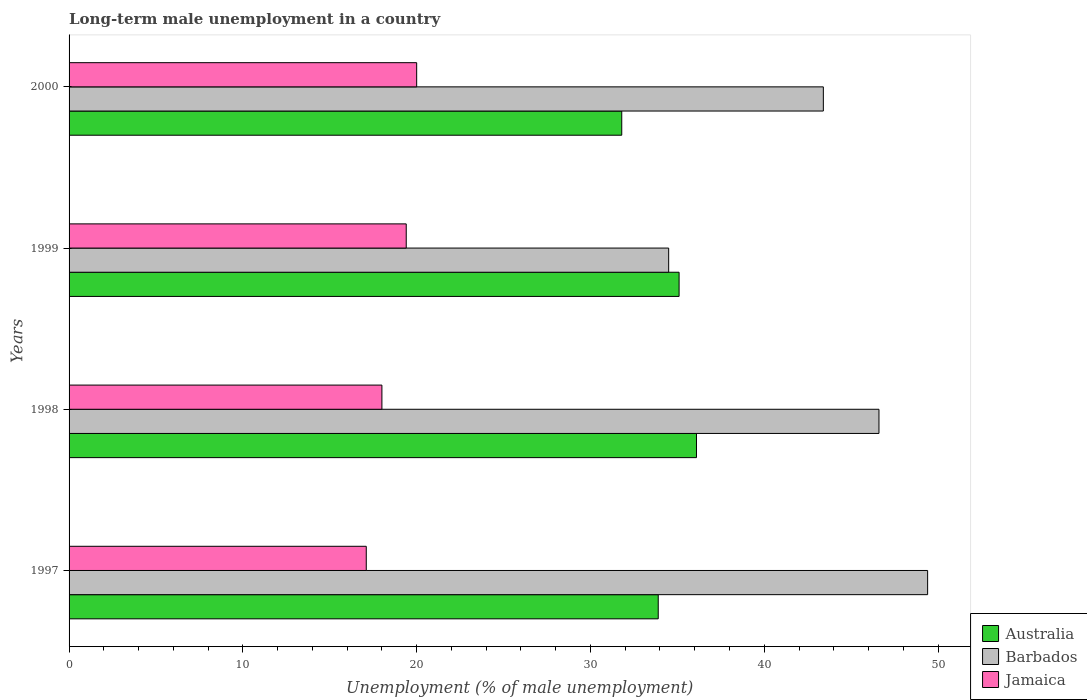How many bars are there on the 1st tick from the bottom?
Your answer should be compact. 3. In how many cases, is the number of bars for a given year not equal to the number of legend labels?
Ensure brevity in your answer.  0. What is the percentage of long-term unemployed male population in Australia in 1999?
Your response must be concise. 35.1. Across all years, what is the maximum percentage of long-term unemployed male population in Jamaica?
Give a very brief answer. 20. Across all years, what is the minimum percentage of long-term unemployed male population in Australia?
Your response must be concise. 31.8. In which year was the percentage of long-term unemployed male population in Barbados maximum?
Give a very brief answer. 1997. In which year was the percentage of long-term unemployed male population in Jamaica minimum?
Keep it short and to the point. 1997. What is the total percentage of long-term unemployed male population in Barbados in the graph?
Keep it short and to the point. 173.9. What is the difference between the percentage of long-term unemployed male population in Barbados in 1997 and that in 1998?
Your answer should be very brief. 2.8. What is the difference between the percentage of long-term unemployed male population in Barbados in 1997 and the percentage of long-term unemployed male population in Jamaica in 1999?
Ensure brevity in your answer.  30. What is the average percentage of long-term unemployed male population in Barbados per year?
Make the answer very short. 43.48. In the year 1997, what is the difference between the percentage of long-term unemployed male population in Jamaica and percentage of long-term unemployed male population in Australia?
Make the answer very short. -16.8. In how many years, is the percentage of long-term unemployed male population in Australia greater than 40 %?
Provide a succinct answer. 0. What is the ratio of the percentage of long-term unemployed male population in Jamaica in 1997 to that in 1998?
Offer a very short reply. 0.95. Is the difference between the percentage of long-term unemployed male population in Jamaica in 1998 and 1999 greater than the difference between the percentage of long-term unemployed male population in Australia in 1998 and 1999?
Your answer should be very brief. No. What is the difference between the highest and the second highest percentage of long-term unemployed male population in Australia?
Make the answer very short. 1. What is the difference between the highest and the lowest percentage of long-term unemployed male population in Barbados?
Offer a very short reply. 14.9. In how many years, is the percentage of long-term unemployed male population in Barbados greater than the average percentage of long-term unemployed male population in Barbados taken over all years?
Your answer should be very brief. 2. Is the sum of the percentage of long-term unemployed male population in Barbados in 1998 and 1999 greater than the maximum percentage of long-term unemployed male population in Australia across all years?
Give a very brief answer. Yes. What does the 3rd bar from the top in 2000 represents?
Keep it short and to the point. Australia. What does the 3rd bar from the bottom in 2000 represents?
Your answer should be compact. Jamaica. How many bars are there?
Keep it short and to the point. 12. How many years are there in the graph?
Your answer should be compact. 4. What is the difference between two consecutive major ticks on the X-axis?
Offer a terse response. 10. Are the values on the major ticks of X-axis written in scientific E-notation?
Offer a very short reply. No. Does the graph contain grids?
Ensure brevity in your answer.  No. Where does the legend appear in the graph?
Your answer should be compact. Bottom right. How are the legend labels stacked?
Offer a terse response. Vertical. What is the title of the graph?
Your answer should be compact. Long-term male unemployment in a country. Does "Indonesia" appear as one of the legend labels in the graph?
Your response must be concise. No. What is the label or title of the X-axis?
Provide a succinct answer. Unemployment (% of male unemployment). What is the label or title of the Y-axis?
Provide a succinct answer. Years. What is the Unemployment (% of male unemployment) in Australia in 1997?
Your response must be concise. 33.9. What is the Unemployment (% of male unemployment) of Barbados in 1997?
Give a very brief answer. 49.4. What is the Unemployment (% of male unemployment) of Jamaica in 1997?
Your answer should be very brief. 17.1. What is the Unemployment (% of male unemployment) of Australia in 1998?
Your answer should be compact. 36.1. What is the Unemployment (% of male unemployment) of Barbados in 1998?
Keep it short and to the point. 46.6. What is the Unemployment (% of male unemployment) of Australia in 1999?
Make the answer very short. 35.1. What is the Unemployment (% of male unemployment) of Barbados in 1999?
Offer a terse response. 34.5. What is the Unemployment (% of male unemployment) of Jamaica in 1999?
Make the answer very short. 19.4. What is the Unemployment (% of male unemployment) in Australia in 2000?
Give a very brief answer. 31.8. What is the Unemployment (% of male unemployment) of Barbados in 2000?
Your answer should be very brief. 43.4. What is the Unemployment (% of male unemployment) of Jamaica in 2000?
Your answer should be very brief. 20. Across all years, what is the maximum Unemployment (% of male unemployment) in Australia?
Provide a short and direct response. 36.1. Across all years, what is the maximum Unemployment (% of male unemployment) of Barbados?
Keep it short and to the point. 49.4. Across all years, what is the maximum Unemployment (% of male unemployment) in Jamaica?
Offer a very short reply. 20. Across all years, what is the minimum Unemployment (% of male unemployment) in Australia?
Provide a succinct answer. 31.8. Across all years, what is the minimum Unemployment (% of male unemployment) in Barbados?
Give a very brief answer. 34.5. Across all years, what is the minimum Unemployment (% of male unemployment) in Jamaica?
Ensure brevity in your answer.  17.1. What is the total Unemployment (% of male unemployment) of Australia in the graph?
Your answer should be very brief. 136.9. What is the total Unemployment (% of male unemployment) in Barbados in the graph?
Your answer should be very brief. 173.9. What is the total Unemployment (% of male unemployment) of Jamaica in the graph?
Your answer should be very brief. 74.5. What is the difference between the Unemployment (% of male unemployment) in Australia in 1997 and that in 1998?
Your answer should be compact. -2.2. What is the difference between the Unemployment (% of male unemployment) of Barbados in 1997 and that in 1998?
Keep it short and to the point. 2.8. What is the difference between the Unemployment (% of male unemployment) of Barbados in 1997 and that in 1999?
Ensure brevity in your answer.  14.9. What is the difference between the Unemployment (% of male unemployment) of Jamaica in 1997 and that in 1999?
Provide a short and direct response. -2.3. What is the difference between the Unemployment (% of male unemployment) of Barbados in 1997 and that in 2000?
Your answer should be compact. 6. What is the difference between the Unemployment (% of male unemployment) of Jamaica in 1997 and that in 2000?
Your response must be concise. -2.9. What is the difference between the Unemployment (% of male unemployment) in Australia in 1998 and that in 1999?
Offer a very short reply. 1. What is the difference between the Unemployment (% of male unemployment) in Jamaica in 1998 and that in 1999?
Ensure brevity in your answer.  -1.4. What is the difference between the Unemployment (% of male unemployment) in Jamaica in 1998 and that in 2000?
Provide a short and direct response. -2. What is the difference between the Unemployment (% of male unemployment) in Australia in 1999 and that in 2000?
Offer a very short reply. 3.3. What is the difference between the Unemployment (% of male unemployment) of Barbados in 1999 and that in 2000?
Give a very brief answer. -8.9. What is the difference between the Unemployment (% of male unemployment) of Australia in 1997 and the Unemployment (% of male unemployment) of Jamaica in 1998?
Your response must be concise. 15.9. What is the difference between the Unemployment (% of male unemployment) of Barbados in 1997 and the Unemployment (% of male unemployment) of Jamaica in 1998?
Give a very brief answer. 31.4. What is the difference between the Unemployment (% of male unemployment) of Australia in 1997 and the Unemployment (% of male unemployment) of Jamaica in 1999?
Your response must be concise. 14.5. What is the difference between the Unemployment (% of male unemployment) of Australia in 1997 and the Unemployment (% of male unemployment) of Barbados in 2000?
Keep it short and to the point. -9.5. What is the difference between the Unemployment (% of male unemployment) of Barbados in 1997 and the Unemployment (% of male unemployment) of Jamaica in 2000?
Keep it short and to the point. 29.4. What is the difference between the Unemployment (% of male unemployment) in Barbados in 1998 and the Unemployment (% of male unemployment) in Jamaica in 1999?
Your answer should be very brief. 27.2. What is the difference between the Unemployment (% of male unemployment) in Australia in 1998 and the Unemployment (% of male unemployment) in Jamaica in 2000?
Provide a succinct answer. 16.1. What is the difference between the Unemployment (% of male unemployment) in Barbados in 1998 and the Unemployment (% of male unemployment) in Jamaica in 2000?
Give a very brief answer. 26.6. What is the difference between the Unemployment (% of male unemployment) in Australia in 1999 and the Unemployment (% of male unemployment) in Barbados in 2000?
Your answer should be compact. -8.3. What is the difference between the Unemployment (% of male unemployment) in Australia in 1999 and the Unemployment (% of male unemployment) in Jamaica in 2000?
Your answer should be very brief. 15.1. What is the difference between the Unemployment (% of male unemployment) of Barbados in 1999 and the Unemployment (% of male unemployment) of Jamaica in 2000?
Your answer should be compact. 14.5. What is the average Unemployment (% of male unemployment) of Australia per year?
Provide a succinct answer. 34.23. What is the average Unemployment (% of male unemployment) in Barbados per year?
Give a very brief answer. 43.48. What is the average Unemployment (% of male unemployment) of Jamaica per year?
Provide a short and direct response. 18.62. In the year 1997, what is the difference between the Unemployment (% of male unemployment) in Australia and Unemployment (% of male unemployment) in Barbados?
Give a very brief answer. -15.5. In the year 1997, what is the difference between the Unemployment (% of male unemployment) of Australia and Unemployment (% of male unemployment) of Jamaica?
Keep it short and to the point. 16.8. In the year 1997, what is the difference between the Unemployment (% of male unemployment) in Barbados and Unemployment (% of male unemployment) in Jamaica?
Ensure brevity in your answer.  32.3. In the year 1998, what is the difference between the Unemployment (% of male unemployment) of Barbados and Unemployment (% of male unemployment) of Jamaica?
Give a very brief answer. 28.6. In the year 1999, what is the difference between the Unemployment (% of male unemployment) of Barbados and Unemployment (% of male unemployment) of Jamaica?
Offer a very short reply. 15.1. In the year 2000, what is the difference between the Unemployment (% of male unemployment) of Australia and Unemployment (% of male unemployment) of Jamaica?
Ensure brevity in your answer.  11.8. In the year 2000, what is the difference between the Unemployment (% of male unemployment) in Barbados and Unemployment (% of male unemployment) in Jamaica?
Provide a short and direct response. 23.4. What is the ratio of the Unemployment (% of male unemployment) in Australia in 1997 to that in 1998?
Ensure brevity in your answer.  0.94. What is the ratio of the Unemployment (% of male unemployment) of Barbados in 1997 to that in 1998?
Offer a very short reply. 1.06. What is the ratio of the Unemployment (% of male unemployment) in Australia in 1997 to that in 1999?
Keep it short and to the point. 0.97. What is the ratio of the Unemployment (% of male unemployment) of Barbados in 1997 to that in 1999?
Give a very brief answer. 1.43. What is the ratio of the Unemployment (% of male unemployment) of Jamaica in 1997 to that in 1999?
Your answer should be compact. 0.88. What is the ratio of the Unemployment (% of male unemployment) in Australia in 1997 to that in 2000?
Give a very brief answer. 1.07. What is the ratio of the Unemployment (% of male unemployment) of Barbados in 1997 to that in 2000?
Offer a very short reply. 1.14. What is the ratio of the Unemployment (% of male unemployment) of Jamaica in 1997 to that in 2000?
Provide a succinct answer. 0.85. What is the ratio of the Unemployment (% of male unemployment) of Australia in 1998 to that in 1999?
Keep it short and to the point. 1.03. What is the ratio of the Unemployment (% of male unemployment) of Barbados in 1998 to that in 1999?
Ensure brevity in your answer.  1.35. What is the ratio of the Unemployment (% of male unemployment) of Jamaica in 1998 to that in 1999?
Provide a short and direct response. 0.93. What is the ratio of the Unemployment (% of male unemployment) in Australia in 1998 to that in 2000?
Ensure brevity in your answer.  1.14. What is the ratio of the Unemployment (% of male unemployment) of Barbados in 1998 to that in 2000?
Make the answer very short. 1.07. What is the ratio of the Unemployment (% of male unemployment) in Jamaica in 1998 to that in 2000?
Give a very brief answer. 0.9. What is the ratio of the Unemployment (% of male unemployment) in Australia in 1999 to that in 2000?
Offer a terse response. 1.1. What is the ratio of the Unemployment (% of male unemployment) of Barbados in 1999 to that in 2000?
Ensure brevity in your answer.  0.79. What is the difference between the highest and the second highest Unemployment (% of male unemployment) of Australia?
Your answer should be very brief. 1. What is the difference between the highest and the second highest Unemployment (% of male unemployment) in Barbados?
Offer a terse response. 2.8. What is the difference between the highest and the lowest Unemployment (% of male unemployment) of Barbados?
Provide a succinct answer. 14.9. 